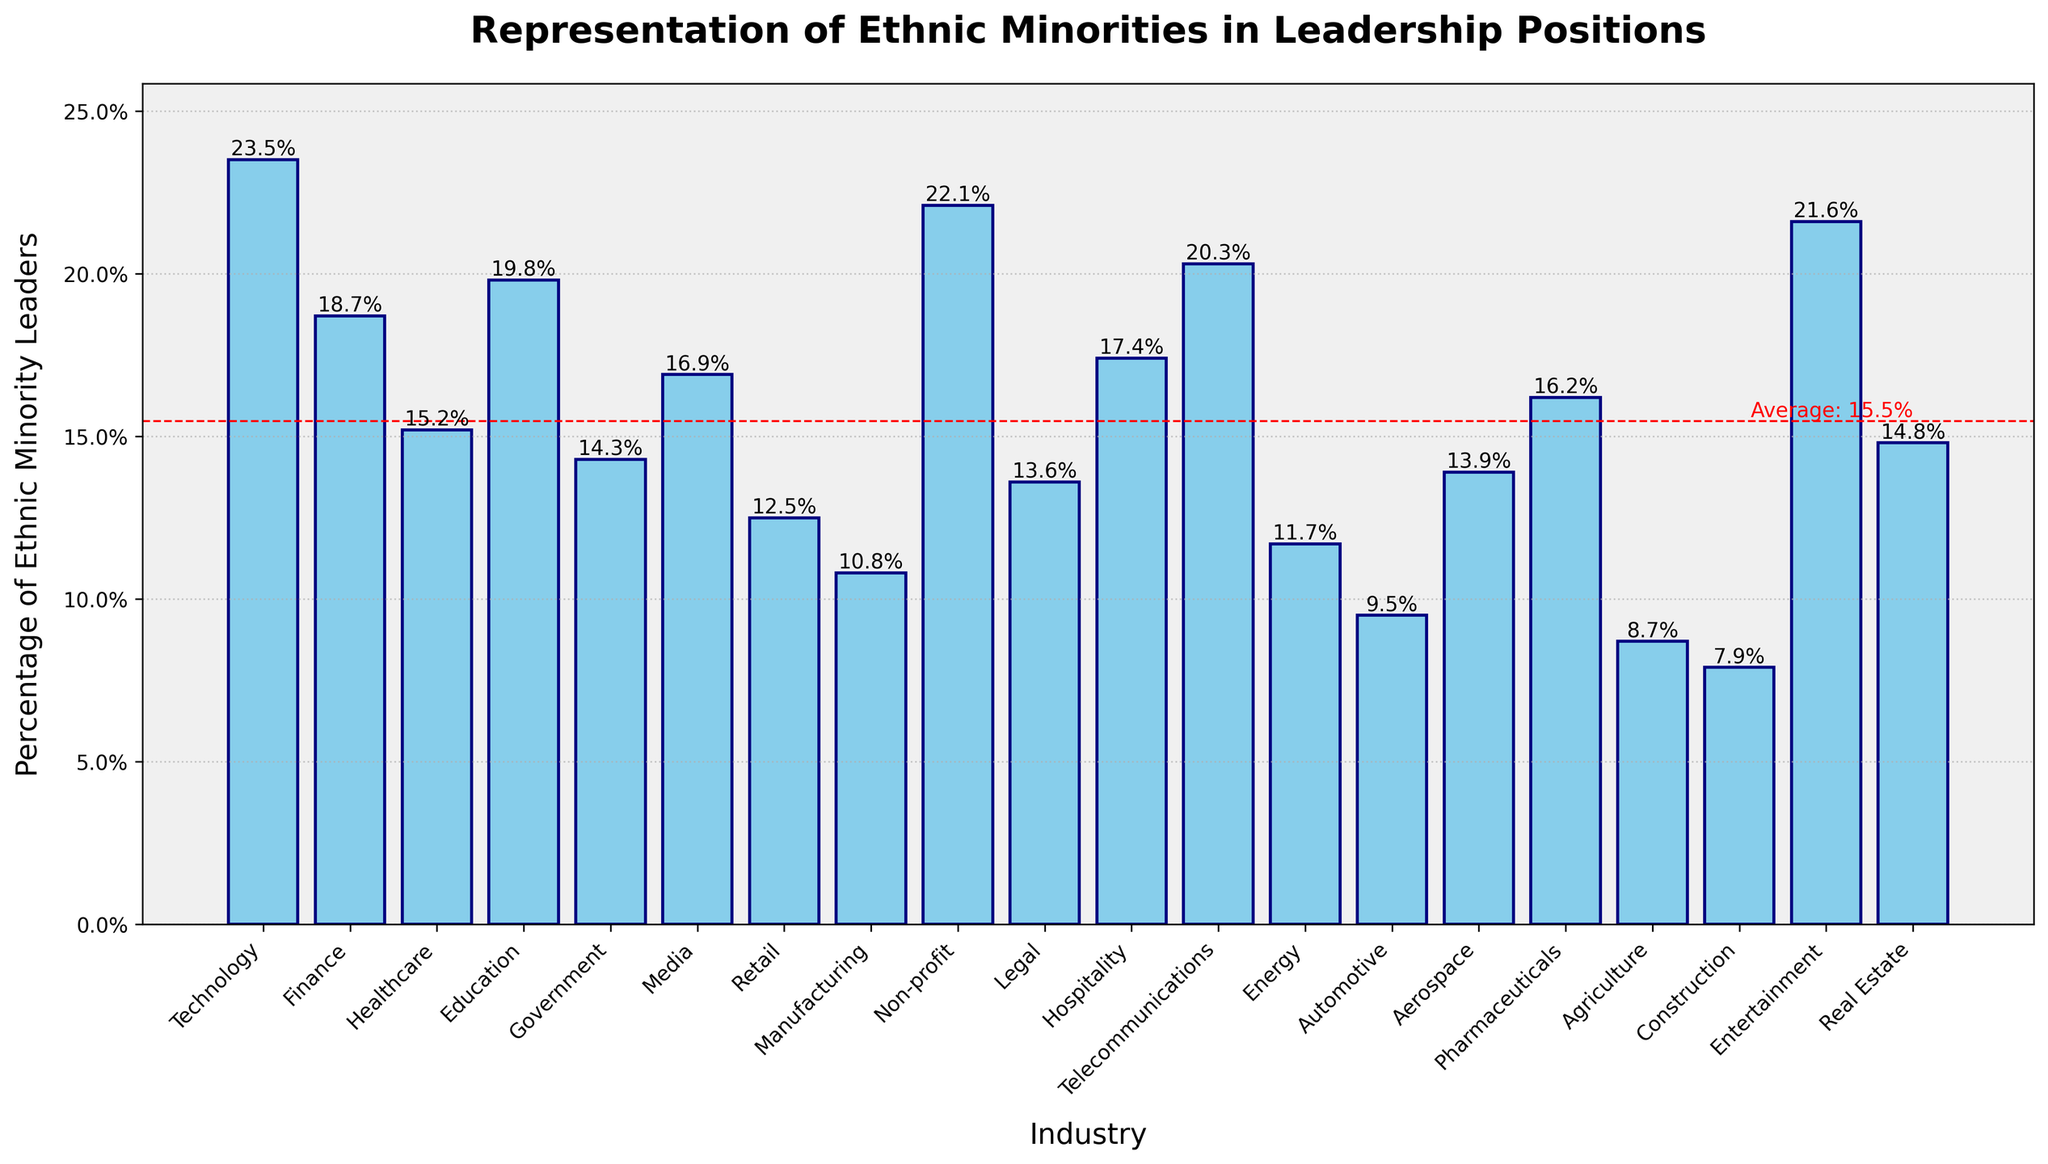Which industry has the highest percentage of ethnic minority leaders? The tallest bar represents the industry with the highest percentage of ethnic minority leaders.
Answer: Technology What is the percentage difference between the industry with the highest and the lowest representation of ethnic minority leaders? Subtract the percentage of the lowest industry (Construction, 7.9%) from the highest industry (Technology, 23.5%). 23.5% - 7.9% = 15.6%
Answer: 15.6% How does the percentage of ethnic minority leaders in Healthcare compare to that in Education? Locate the bars for Healthcare and Education. Healthcare is 15.2%, and Education is 19.8%. Compare these values.
Answer: Education has a higher percentage What is the average percentage of ethnic minority leaders across all industries? Sum all the percentages and divide by the number of industries. (23.5 + 18.7 + 15.2 + 19.8 + 14.3 + 16.9 + 12.5 + 10.8 + 22.1 + 13.6 + 17.4 + 20.3 + 11.7 + 9.5 + 13.9 + 16.2 + 8.7 + 7.9 + 21.6 + 14.8) / 20 = 15.5%
Answer: 15.5% Which industry has almost the same percentage as the average percentage of ethnic minority leaders? The average is approximately 15.5%. Check which industry's bar is close to this value.
Answer: Pharmaceutical (16.2%) How many industries have a percentage of ethnic minority leaders above the average? Count the bars that are taller than the average line at 15.5%.
Answer: 10 Is real estate above or below the average percentage of ethnic minority leaders? Compare the bar for Real Estate (14.8%) to the average line at 15.5%.
Answer: Below Which industry is closest to the average percentage of ethnic minority leaders when excluding the highest and lowest industries? After excluding Technology (23.5%) and Construction (7.9%), find the industry closest to 15.5%.
Answer: Healthcare (15.2%) How does the representation in Media (16.9%) compare to that in Telecommunications (20.3%)? Compare the heights of the bars for Media (16.9%) and Telecommunications (20.3%).
Answer: Telecommunications has a higher percentage What percentage of ethnic minority leaders does the Non-profit sector have, and how does it compare to the Legal sector? Find the bar for Non-profit (22.1%) and compare it to Legal (13.6%).
Answer: Non-profit has a higher percentage (22.1% vs. 13.6%) 